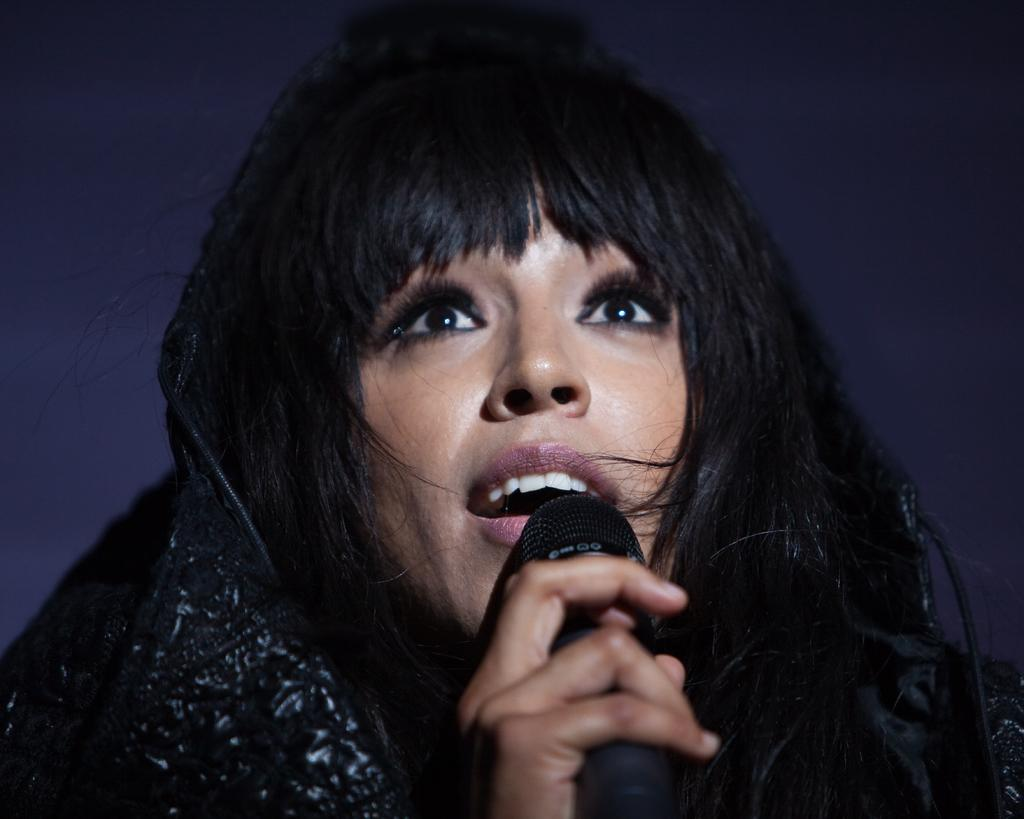What is the main subject of the image? The main subject of the image is a woman. What is the woman holding in the image? The woman is holding a mic. What type of cap is the woman wearing in the image? There is no cap visible in the image; the woman is not wearing a cap. Where is the woman performing in the image? The provided facts do not mention a specific location, such as a street, so it cannot be determined from the image. 